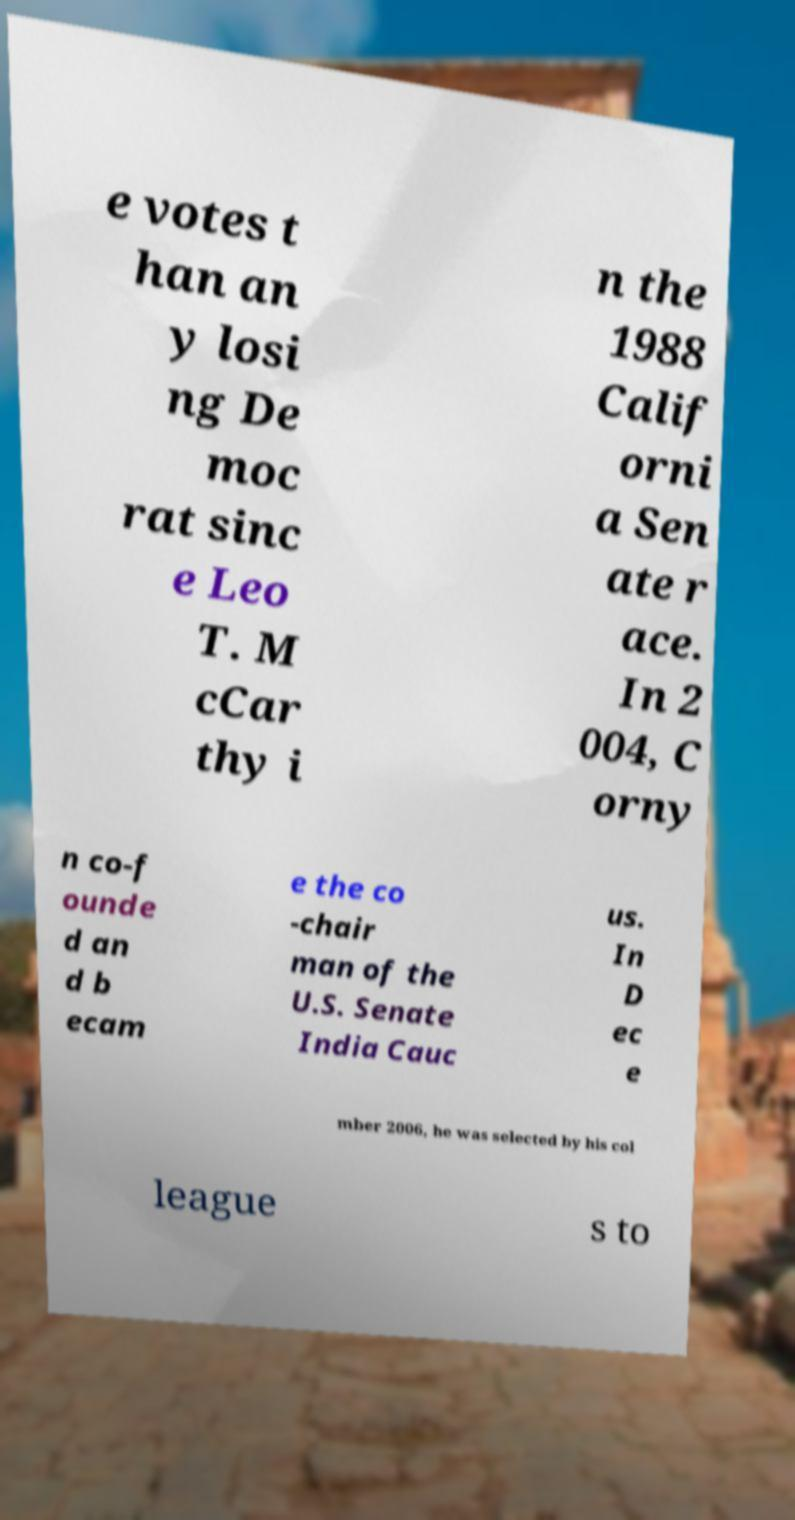Could you extract and type out the text from this image? e votes t han an y losi ng De moc rat sinc e Leo T. M cCar thy i n the 1988 Calif orni a Sen ate r ace. In 2 004, C orny n co-f ounde d an d b ecam e the co -chair man of the U.S. Senate India Cauc us. In D ec e mber 2006, he was selected by his col league s to 